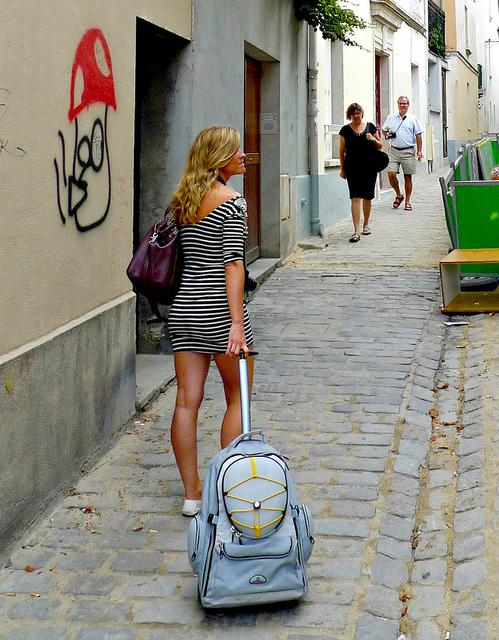Where might the lady on the sidewalk be going? Please explain your reasoning. vacation. She is likely going on vacation judging by the casual style of her dress and luggage. 